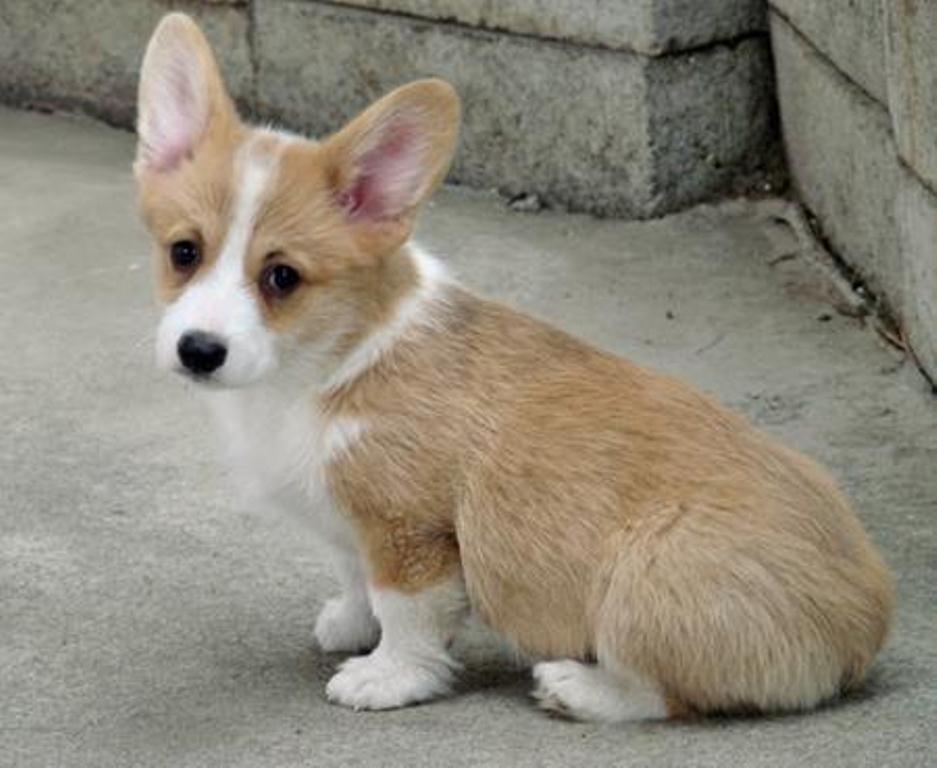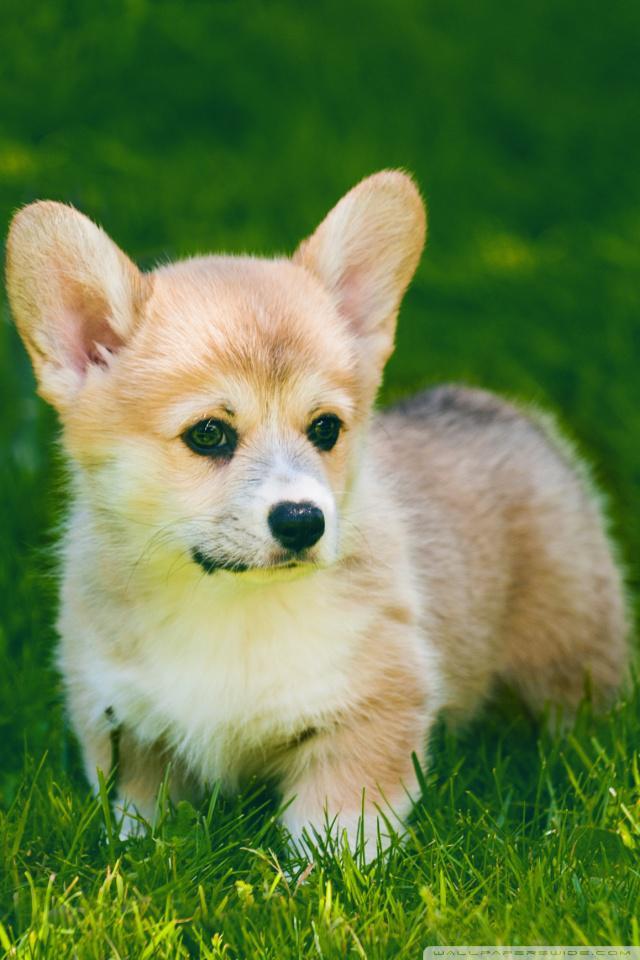The first image is the image on the left, the second image is the image on the right. Analyze the images presented: Is the assertion "Two dogs are lying in the grass in the image on the right." valid? Answer yes or no. No. The first image is the image on the left, the second image is the image on the right. For the images shown, is this caption "The right image contains exactly two dogs." true? Answer yes or no. No. 